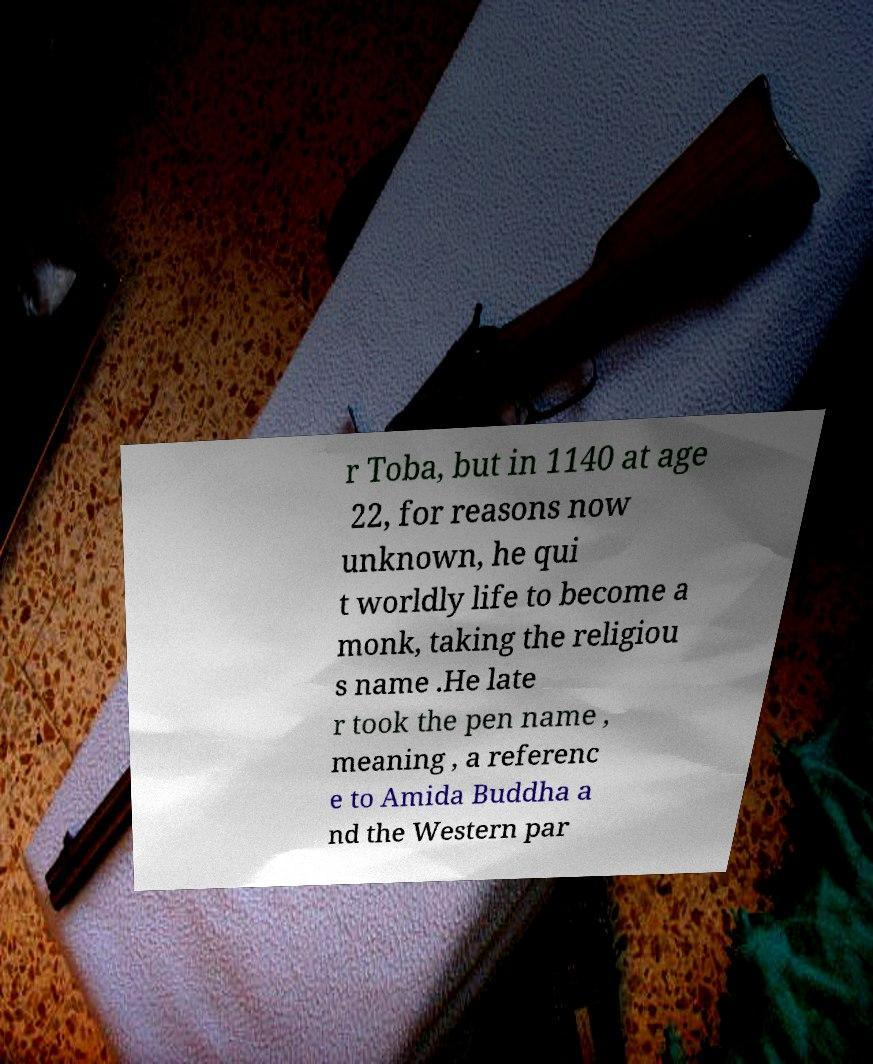Can you read and provide the text displayed in the image?This photo seems to have some interesting text. Can you extract and type it out for me? r Toba, but in 1140 at age 22, for reasons now unknown, he qui t worldly life to become a monk, taking the religiou s name .He late r took the pen name , meaning , a referenc e to Amida Buddha a nd the Western par 